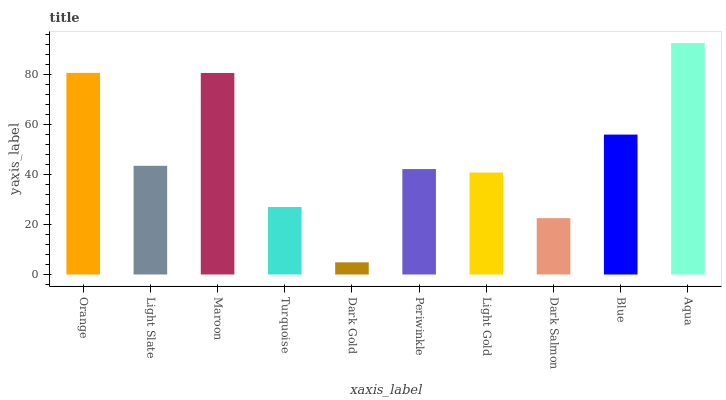Is Dark Gold the minimum?
Answer yes or no. Yes. Is Aqua the maximum?
Answer yes or no. Yes. Is Light Slate the minimum?
Answer yes or no. No. Is Light Slate the maximum?
Answer yes or no. No. Is Orange greater than Light Slate?
Answer yes or no. Yes. Is Light Slate less than Orange?
Answer yes or no. Yes. Is Light Slate greater than Orange?
Answer yes or no. No. Is Orange less than Light Slate?
Answer yes or no. No. Is Light Slate the high median?
Answer yes or no. Yes. Is Periwinkle the low median?
Answer yes or no. Yes. Is Periwinkle the high median?
Answer yes or no. No. Is Turquoise the low median?
Answer yes or no. No. 